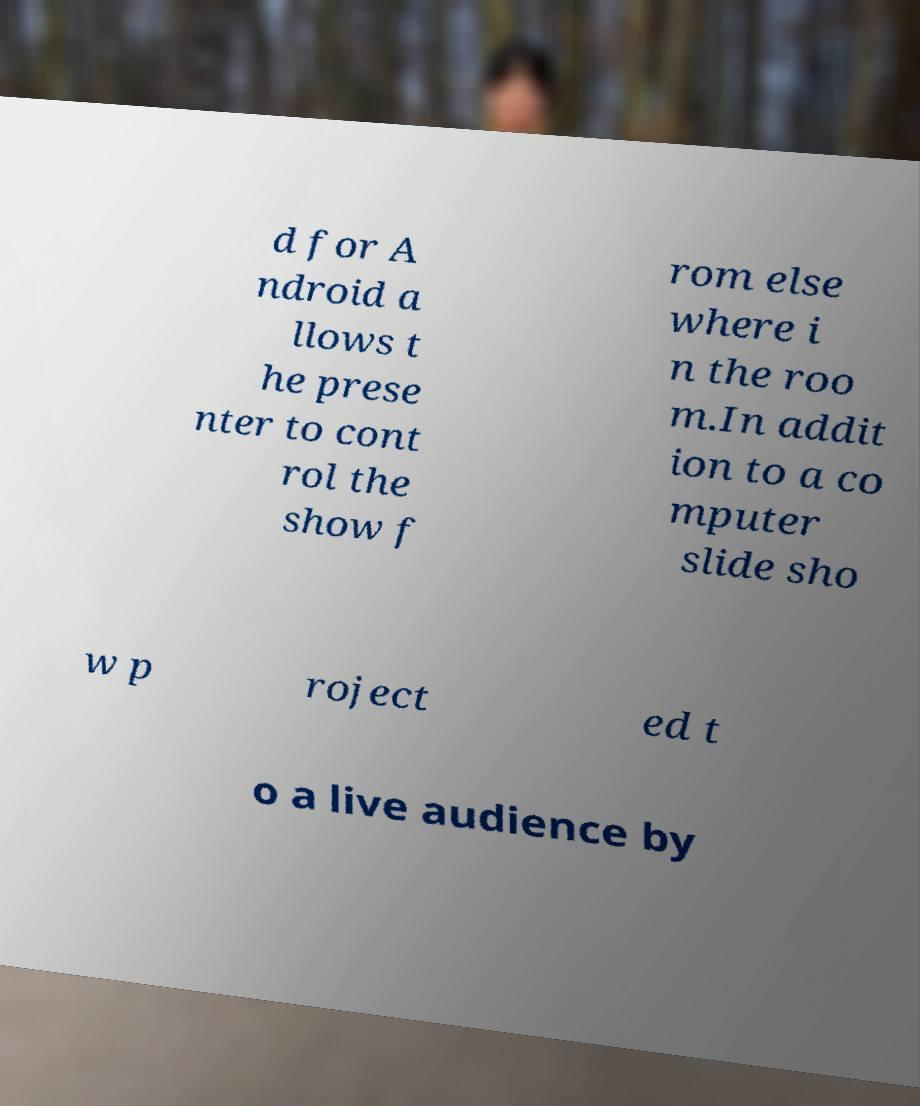There's text embedded in this image that I need extracted. Can you transcribe it verbatim? d for A ndroid a llows t he prese nter to cont rol the show f rom else where i n the roo m.In addit ion to a co mputer slide sho w p roject ed t o a live audience by 